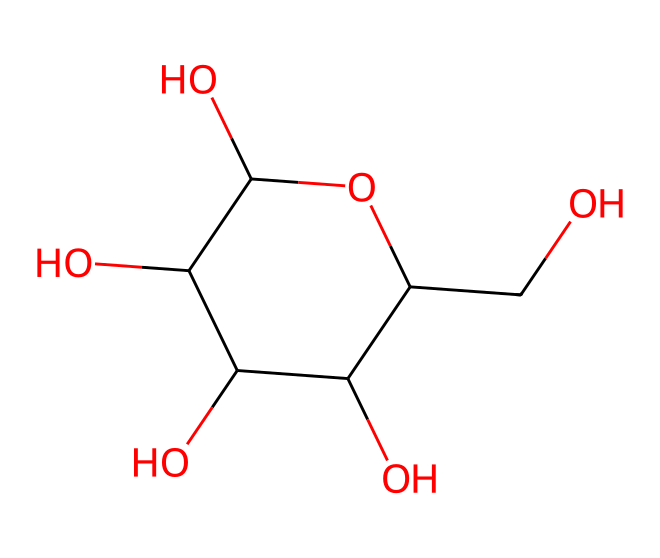What is the name of this chemical? The chemical represented by the SMILES string is glucose, which is a common sugar. The presence of multiple hydroxyl (-OH) groups, a characteristic ring structure, and carbon backbone confirms this.
Answer: glucose How many carbon atoms are in this molecule? By analyzing the SMILES representation, we can count the 'C' characters. This molecule has six carbon atoms in total, confirming it as a hexose sugar.
Answer: six What type of compound is glucose? Glucose is classified as an aliphatic compound, as it consists primarily of carbon and hydrogen atoms arranged in straight or branched chains, despite having a ring structure.
Answer: aliphatic How many hydroxyl groups are present in glucose? By scanning the structure for -OH groups in the molecular formula, we find there are five hydroxyl groups in glucose, which contribute to its chemical properties.
Answer: five What is the molecular formula of this compound? The molecular formula can be derived from the structure and counts of each atom, leading to C6H12O6. This formula aligns with the known composition of glucose.
Answer: C6H12O6 What functional groups are present in glucose? The molecule contains hydroxyl (-OH) groups, which are alcohol functional groups. Each oxygen bonded to hydrogen signifies the presence of these functional groups in the structure.
Answer: hydroxyl What role does glucose play in baking? Glucose serves as a sweetener and is involved in fermentation processes, contributing to the browning reactions during baking due to its reactive nature with other molecules when heated.
Answer: sweetener 